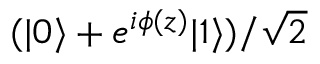Convert formula to latex. <formula><loc_0><loc_0><loc_500><loc_500>( | { 0 } \rangle + e ^ { i \phi ( z ) } | { 1 } \rangle ) / \sqrt { 2 }</formula> 